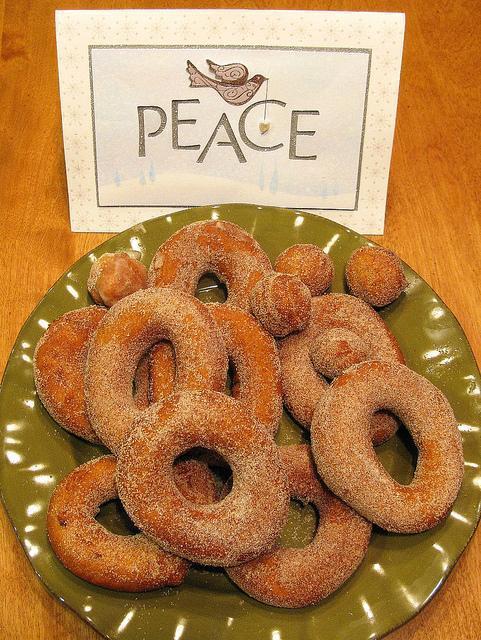How many donuts are there?
Give a very brief answer. 13. 